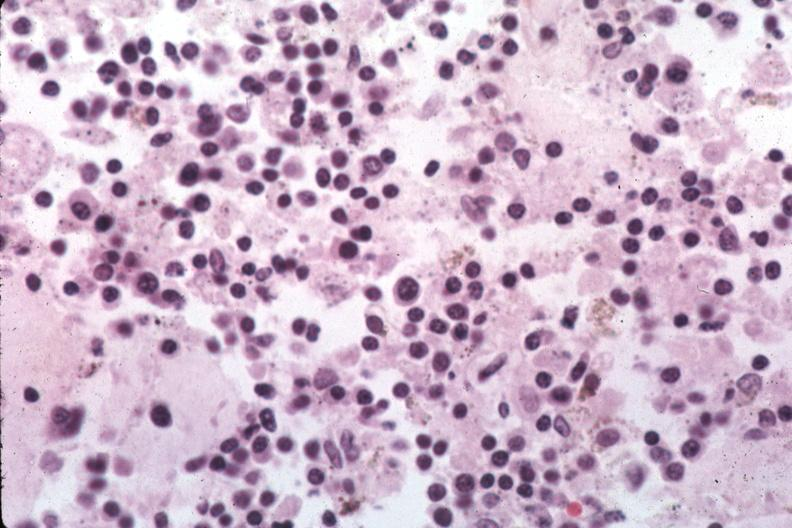what does this image show?
Answer the question using a single word or phrase. Organisms are easily evident 